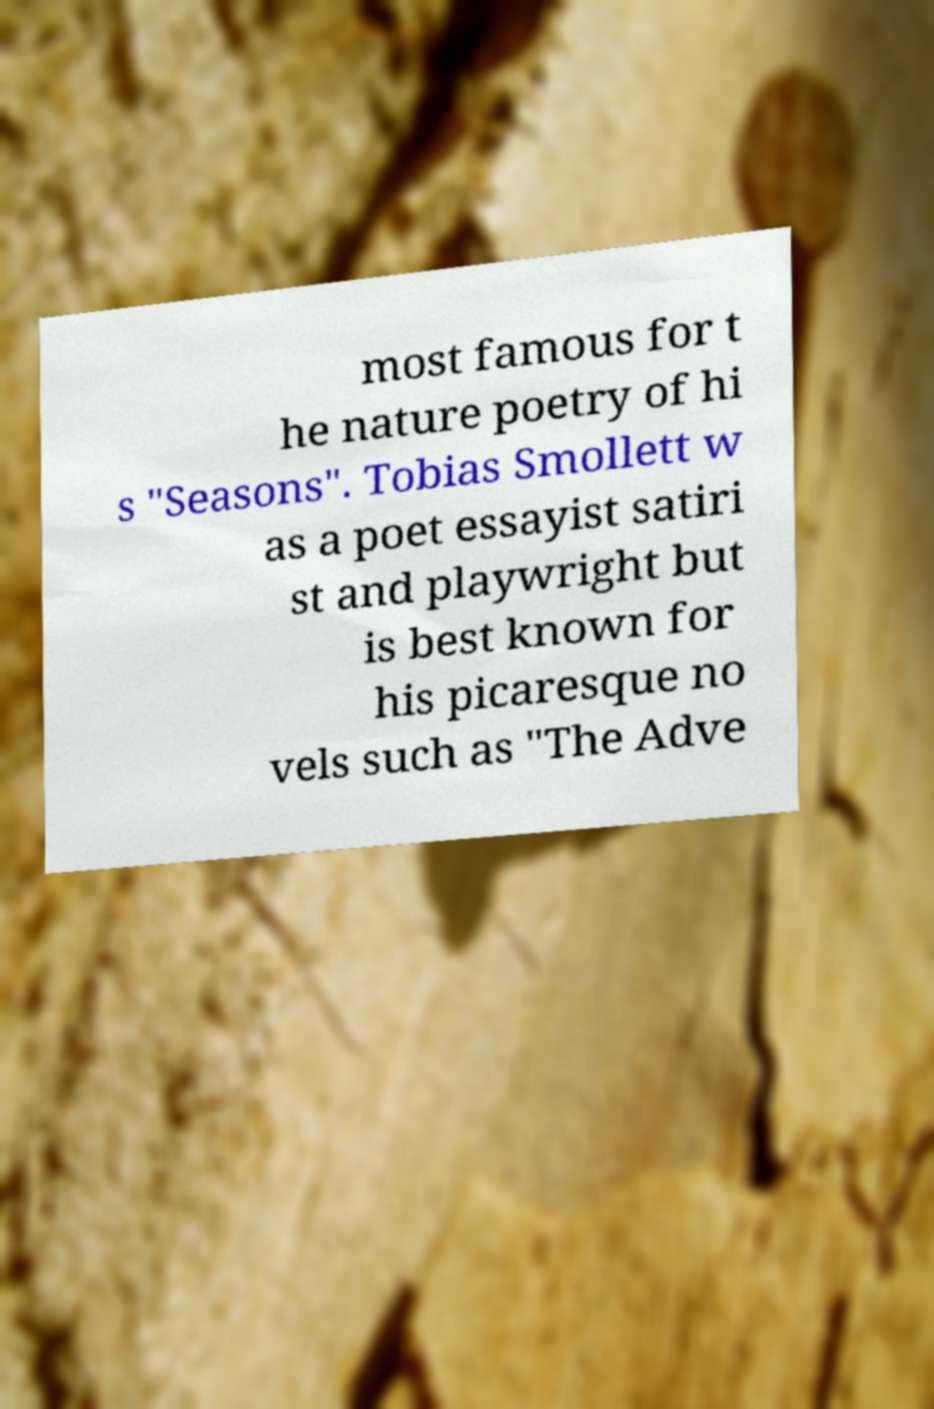For documentation purposes, I need the text within this image transcribed. Could you provide that? most famous for t he nature poetry of hi s "Seasons". Tobias Smollett w as a poet essayist satiri st and playwright but is best known for his picaresque no vels such as "The Adve 